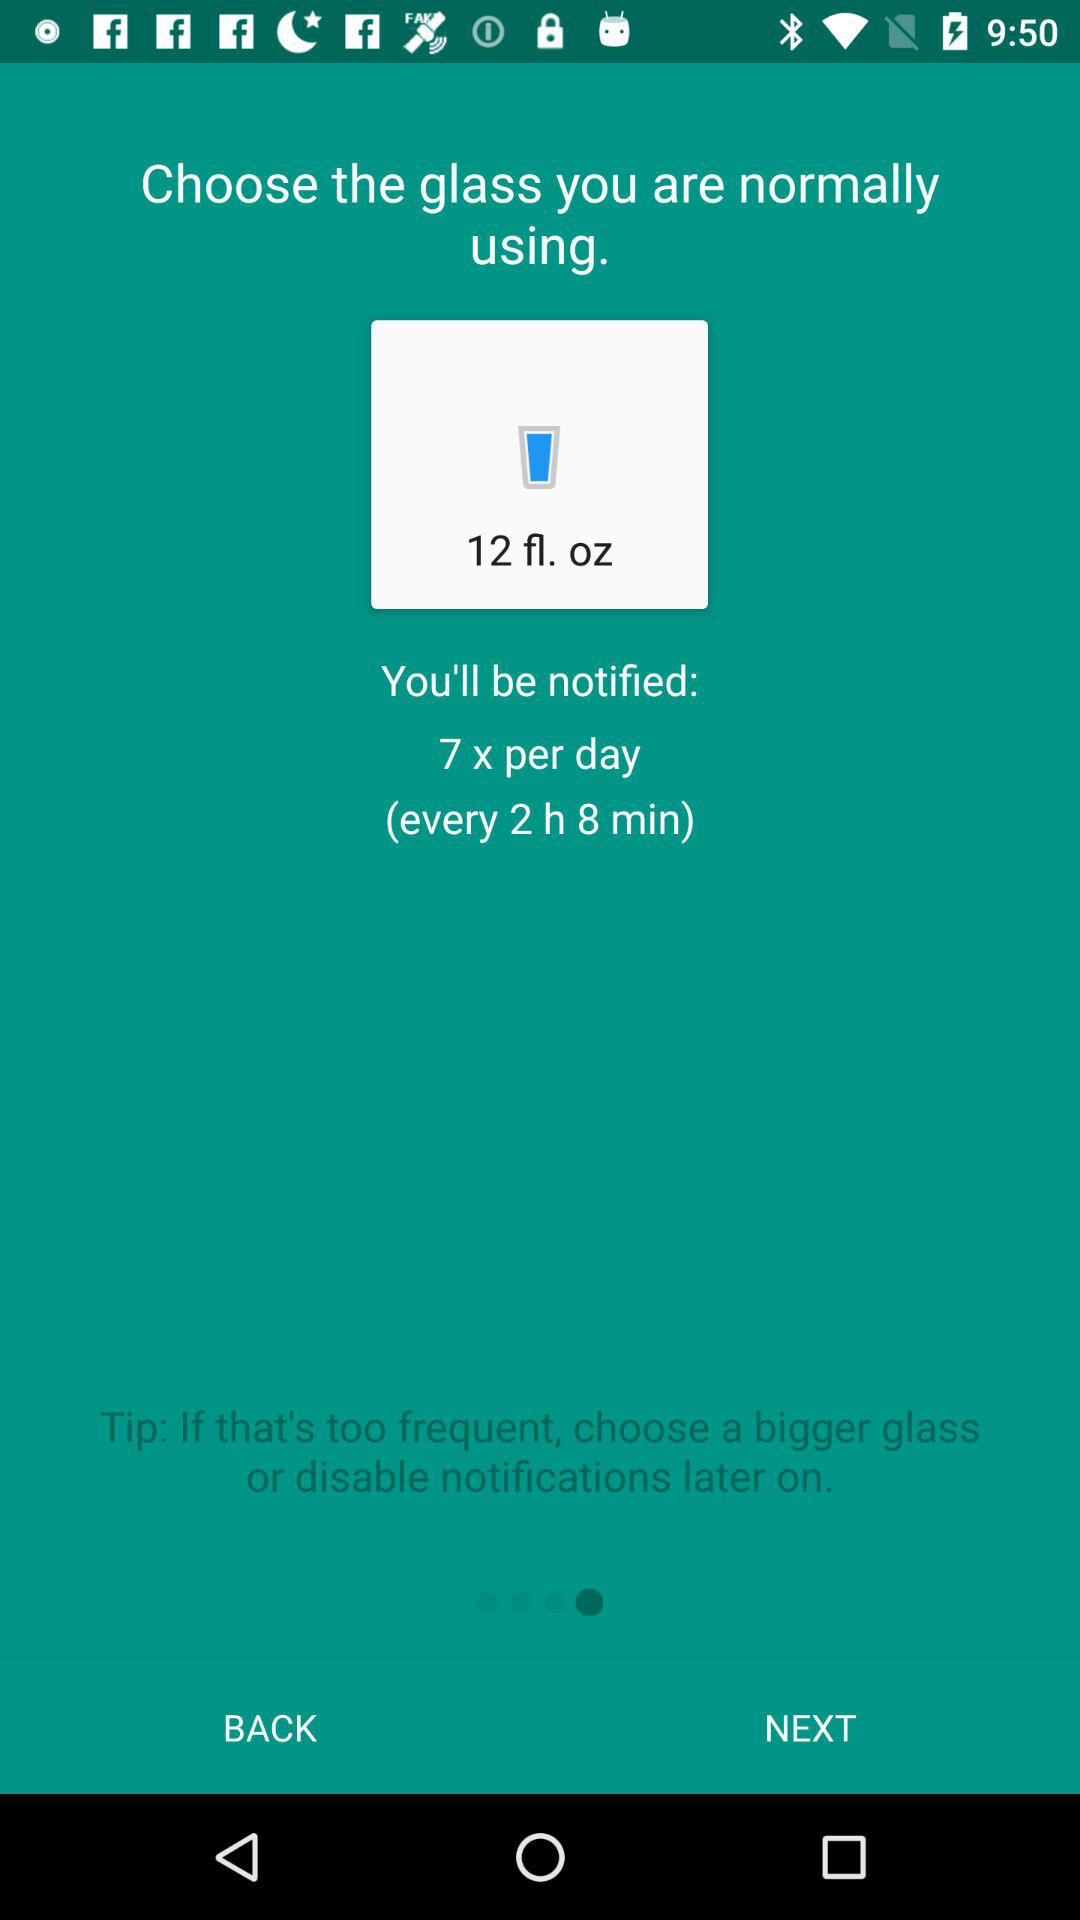What is the capacity of the glass? The capacity of the glass is 12 fluid ounces. 